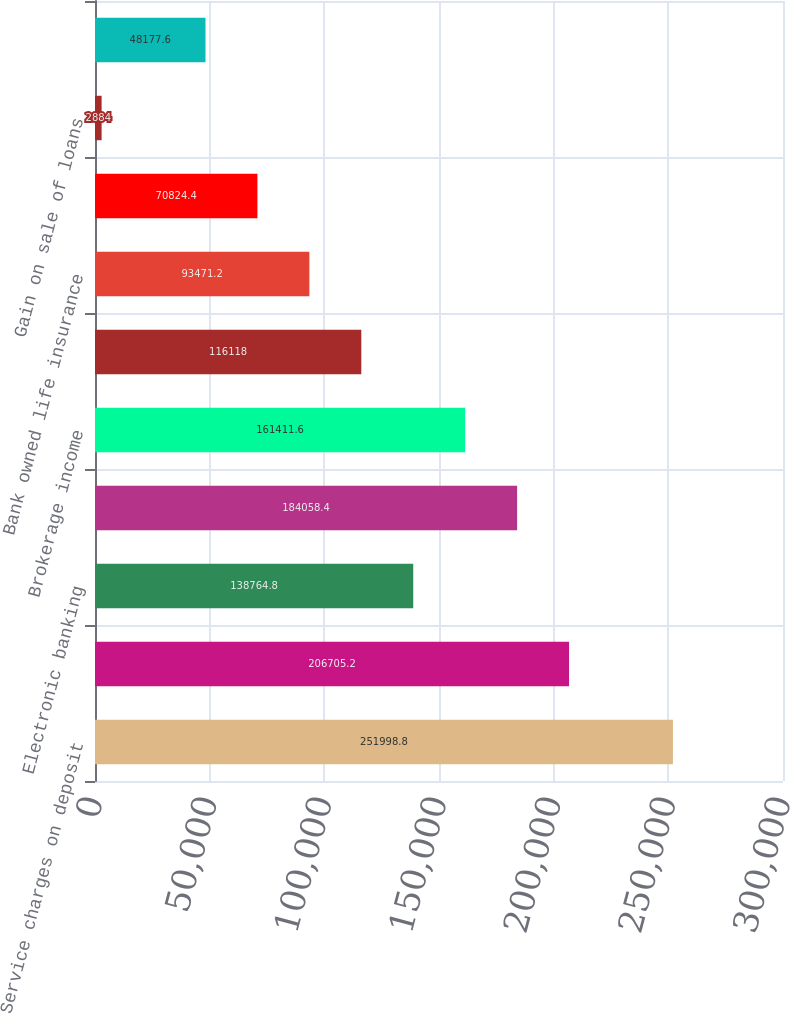Convert chart to OTSL. <chart><loc_0><loc_0><loc_500><loc_500><bar_chart><fcel>Service charges on deposit<fcel>Trust services<fcel>Electronic banking<fcel>Mortgage banking income<fcel>Brokerage income<fcel>Insurance income<fcel>Bank owned life insurance<fcel>Capital markets fees<fcel>Gain on sale of loans<fcel>Automobile operating lease<nl><fcel>251999<fcel>206705<fcel>138765<fcel>184058<fcel>161412<fcel>116118<fcel>93471.2<fcel>70824.4<fcel>2884<fcel>48177.6<nl></chart> 